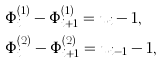Convert formula to latex. <formula><loc_0><loc_0><loc_500><loc_500>& \Phi _ { i } ^ { ( 1 ) } - \Phi _ { i + 1 } ^ { ( 1 ) } = u _ { i } - 1 , \\ & \Phi _ { i } ^ { ( 2 ) } - \Phi _ { i + 1 } ^ { ( 2 ) } = u _ { i - 1 } - 1 ,</formula> 